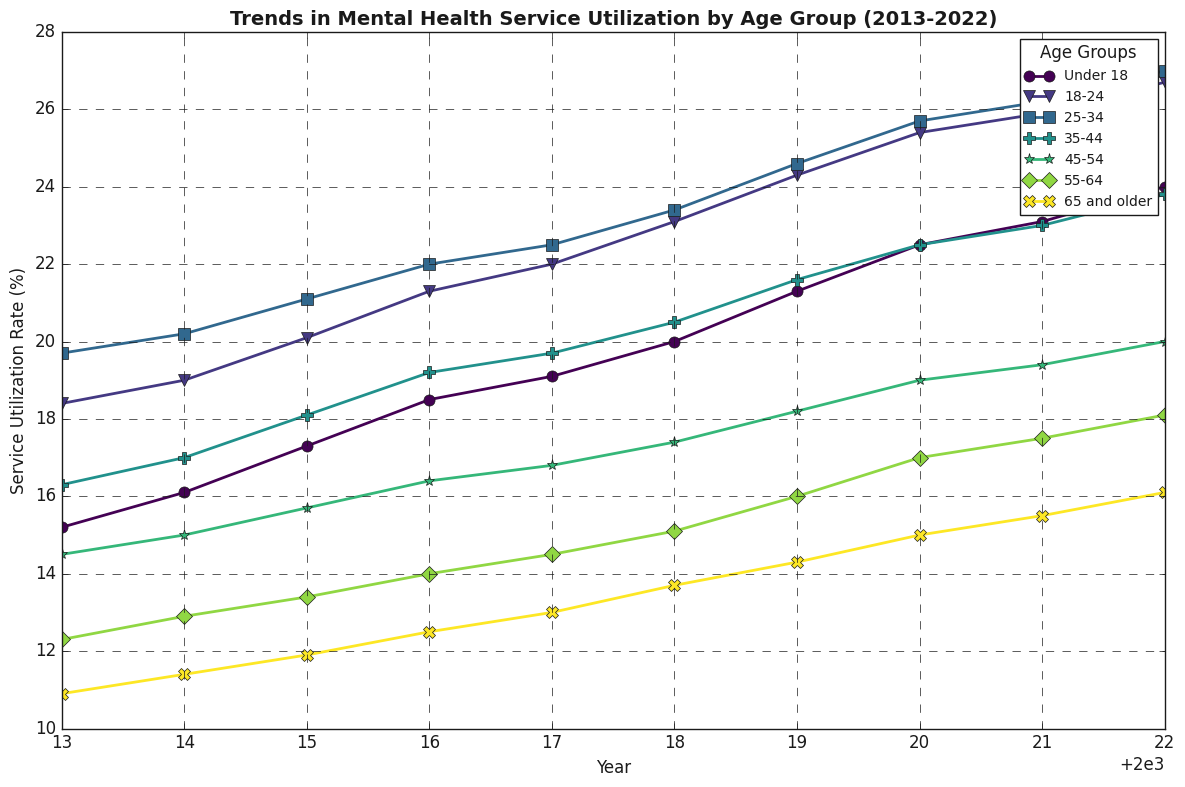Which age group shows the highest mental health service utilization rate in 2022? Look at the 2022 data points and identify the age group with the highest rate. The value for the 18-24 age group is the highest at 26.7%.
Answer: 18-24 Which age group had the lowest mental health service utilization rate in 2013? Look at the 2013 data points and identify the age group with the lowest rate. The value for the 65 and older age group is the lowest at 10.9%.
Answer: 65 and older By how many percentage points did the mental health service utilization rate increase for the under 18 age group from 2013 to 2022? Subtract the 2013 value from the 2022 value for the under 18 age group: 24.0 - 15.2 = 8.8 percentage points.
Answer: 8.8 Which age group saw the largest increase in service utilization from 2013 to 2022? Calculate the difference in values for each age group between 2013 and 2022, then identify the largest increase. The 18-24 age group saw the largest increase from 18.4% to 26.7%, an increase of 8.3%.
Answer: 18-24 What was the overall trend in mental health service utilization rates across all age groups from 2013 to 2022? Observing the lines in the plot across all age groups from 2013 to 2022, they all show an upward trend.
Answer: Increasing Among the age groups 25-34 and 45-54, which had a higher utilization rate in 2016, and by how much? In 2016, the value for 25-34 was 22.0%, and the value for 45-54 was 16.4%. The difference is 22.0% - 16.4% = 5.6 percentage points, with 25-34 having the higher rate.
Answer: 25-34, 5.6 Did any age group show a decrease in their service utilization rate at any point in the data? Inspect the lines for any age group to find downward trends. None of the lines show a decrease; all lines depict an increase or a stable trend.
Answer: No Which age group consistently had higher utilization rates than the under 18 group from 2013 to 2022? Compare the under 18 group with other age groups for each year from 2013 to 2022. The 18-24 age group consistently had higher rates each year.
Answer: 18-24 What is the average mental health service utilization rate for the 35-44 age group over the decade? Find the sum of the rates for 35-44 from 2013 to 2022 and divide by the number of years. (16.3 + 17.0 + 18.1 + 19.2 + 19.7 + 20.5 + 21.6 + 22.5 + 23.0 + 23.8) / 10 = 20.17%.
Answer: 20.17 